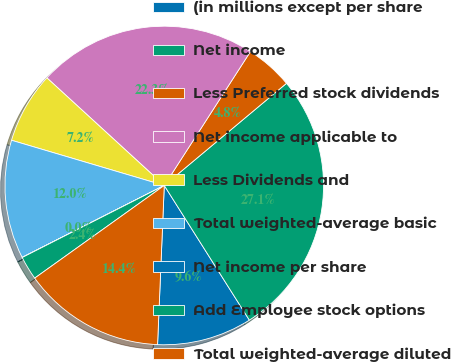<chart> <loc_0><loc_0><loc_500><loc_500><pie_chart><fcel>(in millions except per share<fcel>Net income<fcel>Less Preferred stock dividends<fcel>Net income applicable to<fcel>Less Dividends and<fcel>Total weighted-average basic<fcel>Net income per share<fcel>Add Employee stock options<fcel>Total weighted-average diluted<nl><fcel>9.64%<fcel>27.11%<fcel>4.82%<fcel>22.29%<fcel>7.23%<fcel>12.04%<fcel>0.01%<fcel>2.41%<fcel>14.45%<nl></chart> 